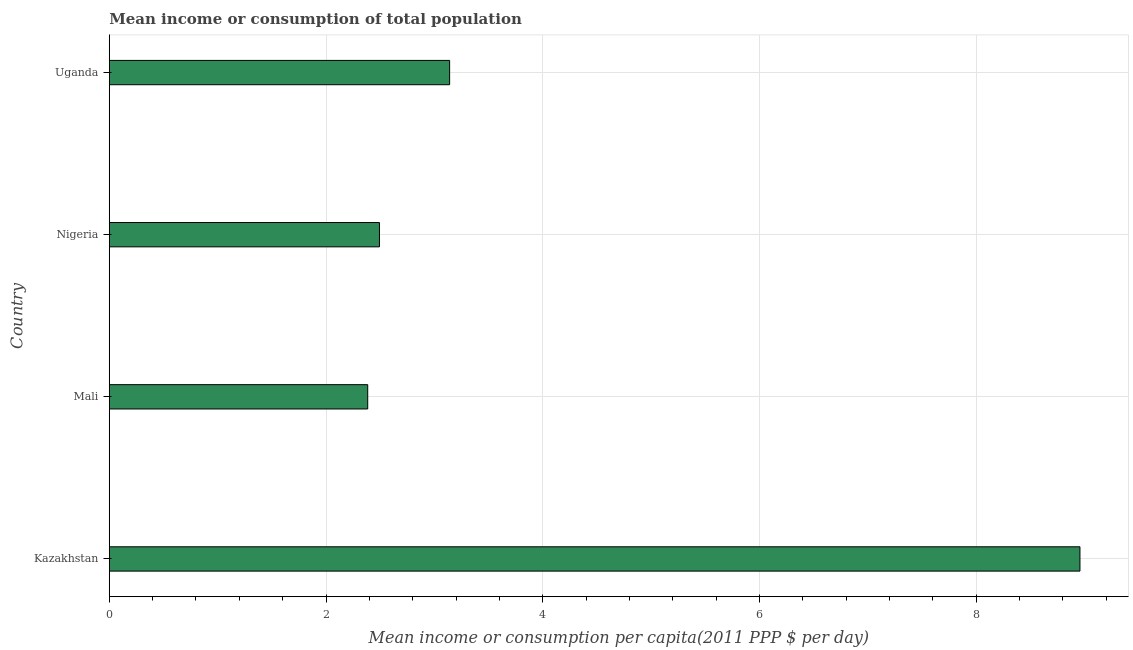What is the title of the graph?
Provide a succinct answer. Mean income or consumption of total population. What is the label or title of the X-axis?
Offer a terse response. Mean income or consumption per capita(2011 PPP $ per day). What is the label or title of the Y-axis?
Your answer should be compact. Country. What is the mean income or consumption in Kazakhstan?
Make the answer very short. 8.96. Across all countries, what is the maximum mean income or consumption?
Give a very brief answer. 8.96. Across all countries, what is the minimum mean income or consumption?
Your answer should be very brief. 2.38. In which country was the mean income or consumption maximum?
Provide a short and direct response. Kazakhstan. In which country was the mean income or consumption minimum?
Keep it short and to the point. Mali. What is the sum of the mean income or consumption?
Your answer should be compact. 16.98. What is the difference between the mean income or consumption in Mali and Uganda?
Offer a terse response. -0.76. What is the average mean income or consumption per country?
Your answer should be very brief. 4.24. What is the median mean income or consumption?
Keep it short and to the point. 2.82. In how many countries, is the mean income or consumption greater than 5.6 $?
Give a very brief answer. 1. What is the ratio of the mean income or consumption in Nigeria to that in Uganda?
Offer a very short reply. 0.79. Is the mean income or consumption in Nigeria less than that in Uganda?
Your answer should be very brief. Yes. Is the difference between the mean income or consumption in Mali and Uganda greater than the difference between any two countries?
Your answer should be very brief. No. What is the difference between the highest and the second highest mean income or consumption?
Your answer should be very brief. 5.82. Is the sum of the mean income or consumption in Kazakhstan and Nigeria greater than the maximum mean income or consumption across all countries?
Your answer should be very brief. Yes. What is the difference between the highest and the lowest mean income or consumption?
Your answer should be compact. 6.57. How many bars are there?
Your answer should be compact. 4. How many countries are there in the graph?
Offer a terse response. 4. What is the difference between two consecutive major ticks on the X-axis?
Your answer should be very brief. 2. Are the values on the major ticks of X-axis written in scientific E-notation?
Your answer should be very brief. No. What is the Mean income or consumption per capita(2011 PPP $ per day) of Kazakhstan?
Offer a terse response. 8.96. What is the Mean income or consumption per capita(2011 PPP $ per day) of Mali?
Your response must be concise. 2.38. What is the Mean income or consumption per capita(2011 PPP $ per day) in Nigeria?
Make the answer very short. 2.49. What is the Mean income or consumption per capita(2011 PPP $ per day) in Uganda?
Your answer should be compact. 3.14. What is the difference between the Mean income or consumption per capita(2011 PPP $ per day) in Kazakhstan and Mali?
Provide a short and direct response. 6.57. What is the difference between the Mean income or consumption per capita(2011 PPP $ per day) in Kazakhstan and Nigeria?
Make the answer very short. 6.46. What is the difference between the Mean income or consumption per capita(2011 PPP $ per day) in Kazakhstan and Uganda?
Your response must be concise. 5.82. What is the difference between the Mean income or consumption per capita(2011 PPP $ per day) in Mali and Nigeria?
Provide a succinct answer. -0.11. What is the difference between the Mean income or consumption per capita(2011 PPP $ per day) in Mali and Uganda?
Your answer should be compact. -0.76. What is the difference between the Mean income or consumption per capita(2011 PPP $ per day) in Nigeria and Uganda?
Offer a very short reply. -0.65. What is the ratio of the Mean income or consumption per capita(2011 PPP $ per day) in Kazakhstan to that in Mali?
Offer a terse response. 3.76. What is the ratio of the Mean income or consumption per capita(2011 PPP $ per day) in Kazakhstan to that in Nigeria?
Your answer should be compact. 3.59. What is the ratio of the Mean income or consumption per capita(2011 PPP $ per day) in Kazakhstan to that in Uganda?
Provide a short and direct response. 2.85. What is the ratio of the Mean income or consumption per capita(2011 PPP $ per day) in Mali to that in Nigeria?
Your response must be concise. 0.96. What is the ratio of the Mean income or consumption per capita(2011 PPP $ per day) in Mali to that in Uganda?
Ensure brevity in your answer.  0.76. What is the ratio of the Mean income or consumption per capita(2011 PPP $ per day) in Nigeria to that in Uganda?
Keep it short and to the point. 0.79. 